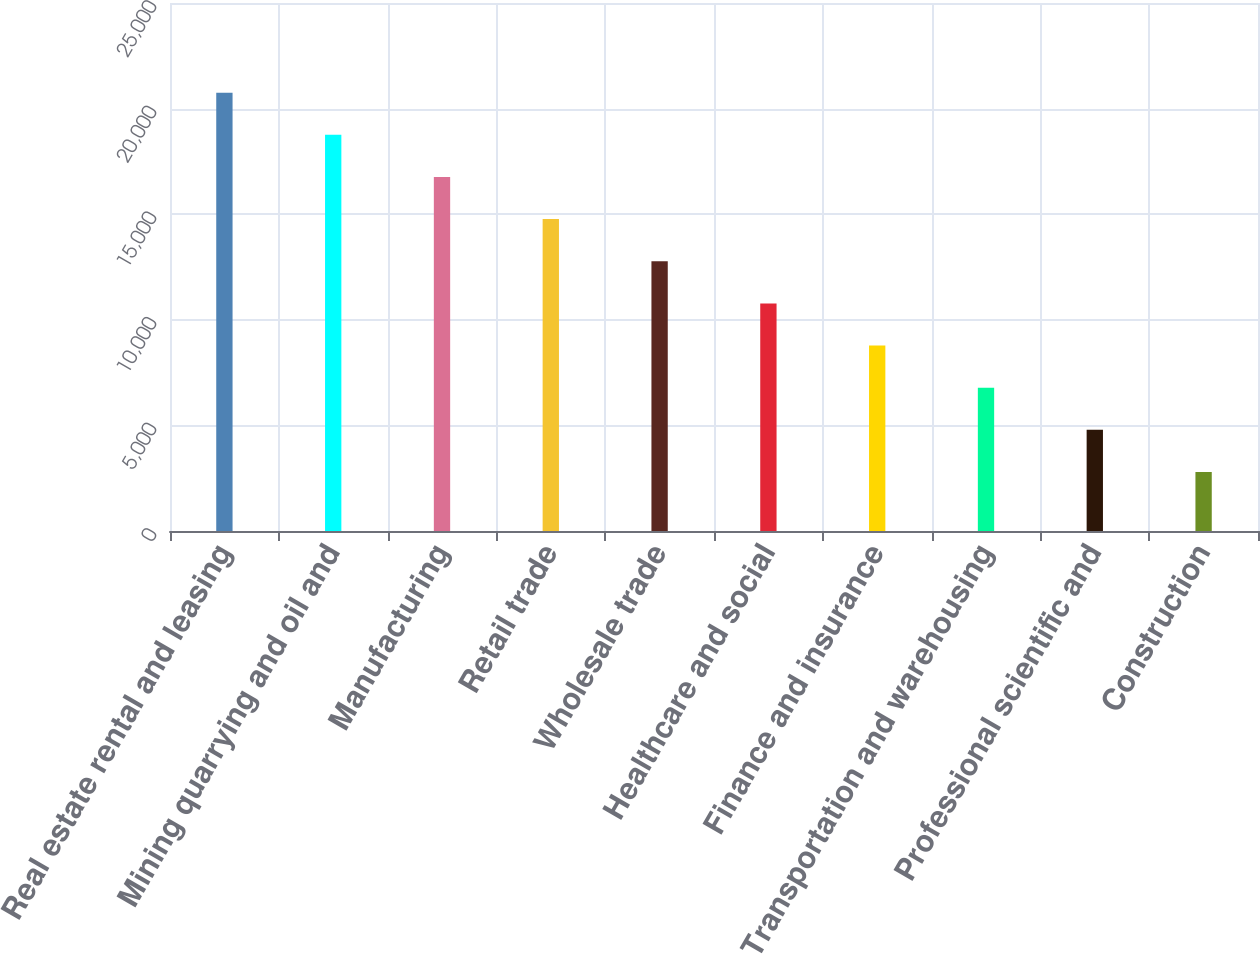Convert chart. <chart><loc_0><loc_0><loc_500><loc_500><bar_chart><fcel>Real estate rental and leasing<fcel>Mining quarrying and oil and<fcel>Manufacturing<fcel>Retail trade<fcel>Wholesale trade<fcel>Healthcare and social<fcel>Finance and insurance<fcel>Transportation and warehousing<fcel>Professional scientific and<fcel>Construction<nl><fcel>20755<fcel>18759.4<fcel>16763.8<fcel>14768.2<fcel>12772.6<fcel>10777<fcel>8781.4<fcel>6785.8<fcel>4790.2<fcel>2794.6<nl></chart> 